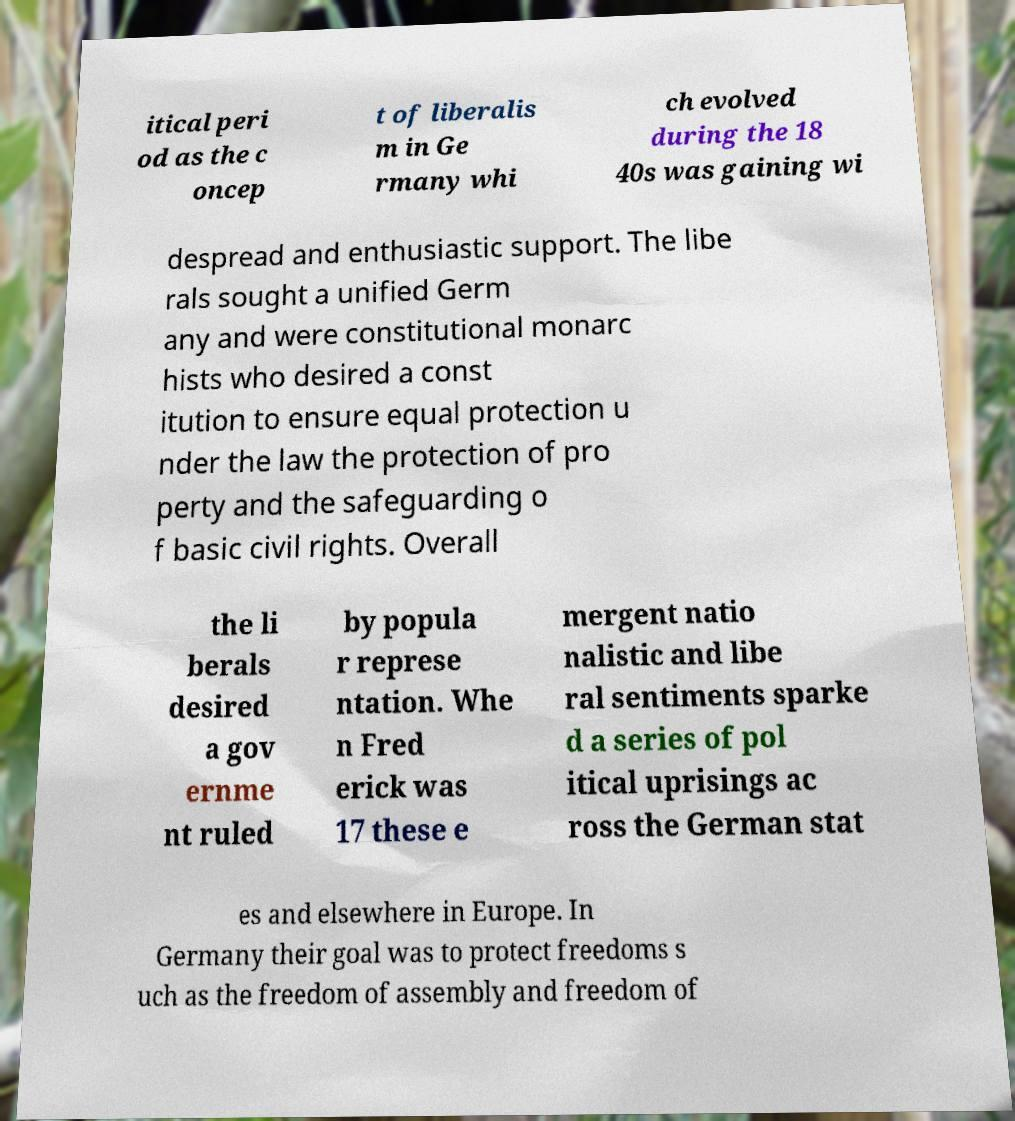Please read and relay the text visible in this image. What does it say? itical peri od as the c oncep t of liberalis m in Ge rmany whi ch evolved during the 18 40s was gaining wi despread and enthusiastic support. The libe rals sought a unified Germ any and were constitutional monarc hists who desired a const itution to ensure equal protection u nder the law the protection of pro perty and the safeguarding o f basic civil rights. Overall the li berals desired a gov ernme nt ruled by popula r represe ntation. Whe n Fred erick was 17 these e mergent natio nalistic and libe ral sentiments sparke d a series of pol itical uprisings ac ross the German stat es and elsewhere in Europe. In Germany their goal was to protect freedoms s uch as the freedom of assembly and freedom of 